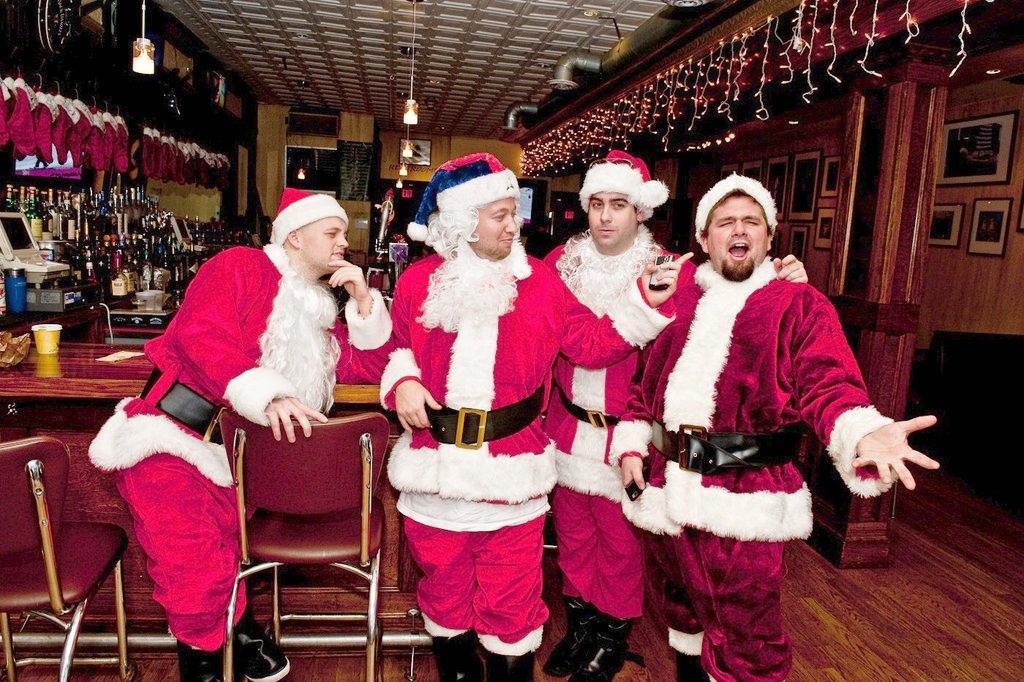How would you summarize this image in a sentence or two? This is the picture of four people wearing Santa dresses and behind them there are some bottles on the table and decorated with some lights. 